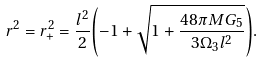<formula> <loc_0><loc_0><loc_500><loc_500>r ^ { 2 } = r ^ { 2 } _ { + } = \frac { l ^ { 2 } } { 2 } { \left ( - 1 + \sqrt { 1 + \frac { 4 8 \pi M G _ { 5 } } { 3 \Omega _ { 3 } l ^ { 2 } } } \right ) } .</formula> 